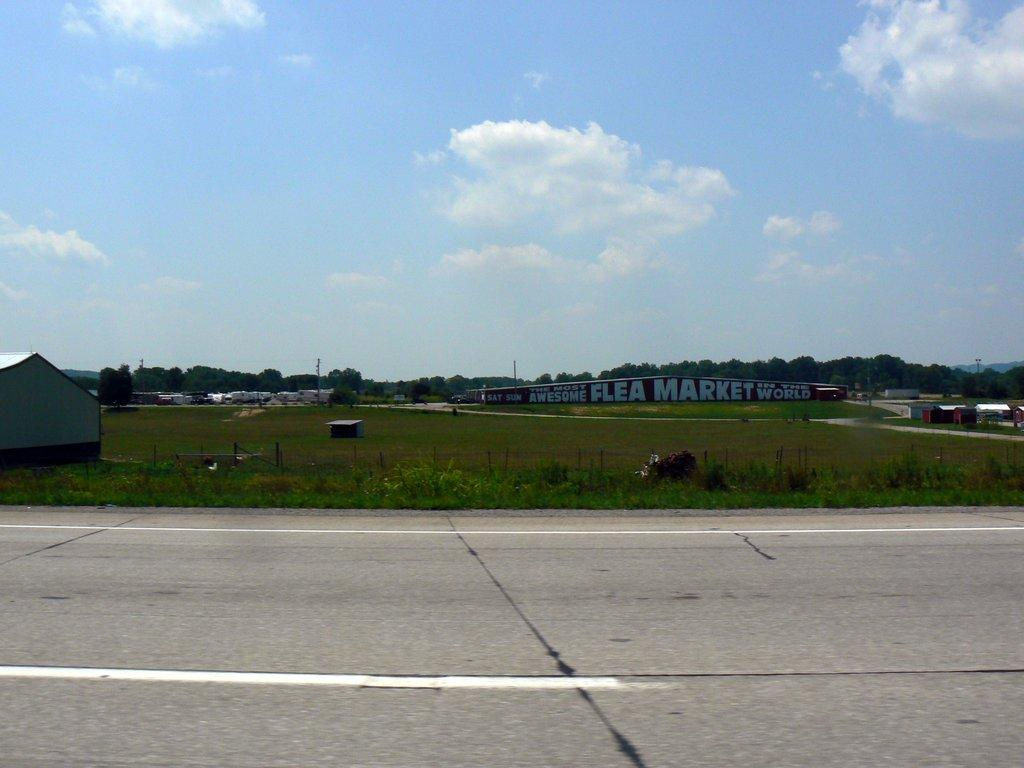What can be seen in the sky in the image? The sky with clouds is visible in the image. What type of vegetation is present in the image? There are trees in the image. What are the tall, thin structures in the image? There are poles in the image. What type of structures are present in the image for storage or shelter? There are sheds in the image. What type of large structures are present in the image? There are buildings in the image. What type of ground surface is visible in the image? Grass is present in the image. What type of transportation infrastructure is visible in the image? There is a road visible in the image. What type of spark can be seen coming from the lamp in the image? There is no lamp present in the image, so it is not possible to determine if there is any spark coming from it. What type of coach is visible in the image? There is no coach present in the image. 